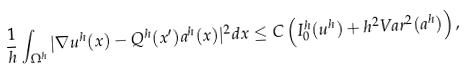Convert formula to latex. <formula><loc_0><loc_0><loc_500><loc_500>\frac { 1 } { h } \int _ { \Omega ^ { h } } | \nabla u ^ { h } ( x ) - Q ^ { h } ( x ^ { \prime } ) a ^ { h } ( x ) | ^ { 2 } d x \leq C \left ( I _ { 0 } ^ { h } ( u ^ { h } ) + h ^ { 2 } V a r ^ { 2 } ( a ^ { h } ) \right ) ,</formula> 